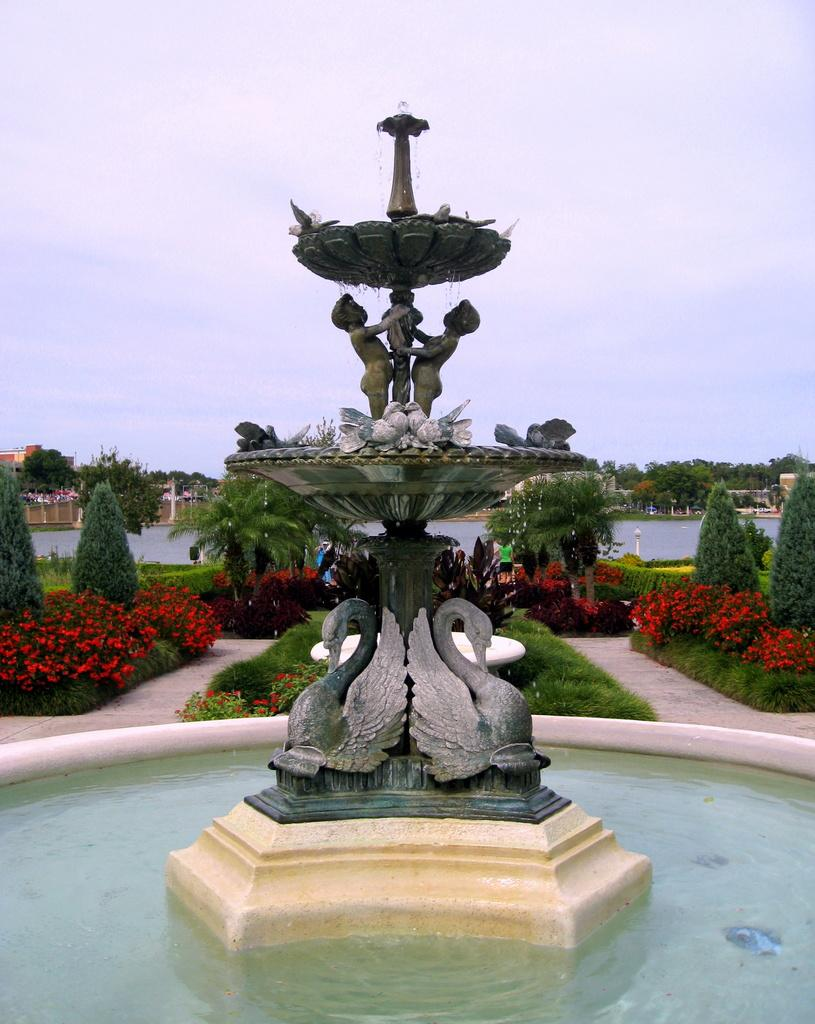What is the main feature in the image? There is a fountain in the image. What is at the base of the fountain? There is water at the bottom of the fountain. What can be seen in the background of the image? There are trees and plants in the background of the image. What is visible at the top of the image? The sky is visible at the top of the image. What type of mitten is being used to control the fountain in the image? There is no mitten present in the image, and it is not being used to control the fountain. 